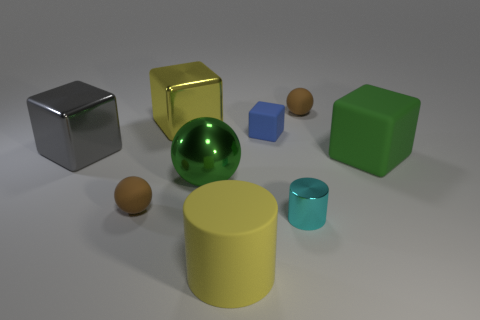Subtract all big green blocks. How many blocks are left? 3 Subtract all brown spheres. How many spheres are left? 1 Subtract all blocks. How many objects are left? 5 Subtract all purple balls. Subtract all brown cylinders. How many balls are left? 3 Subtract all brown spheres. How many green blocks are left? 1 Subtract all shiny cylinders. Subtract all big matte blocks. How many objects are left? 7 Add 3 shiny cubes. How many shiny cubes are left? 5 Add 7 green blocks. How many green blocks exist? 8 Subtract 0 purple cubes. How many objects are left? 9 Subtract 2 cylinders. How many cylinders are left? 0 